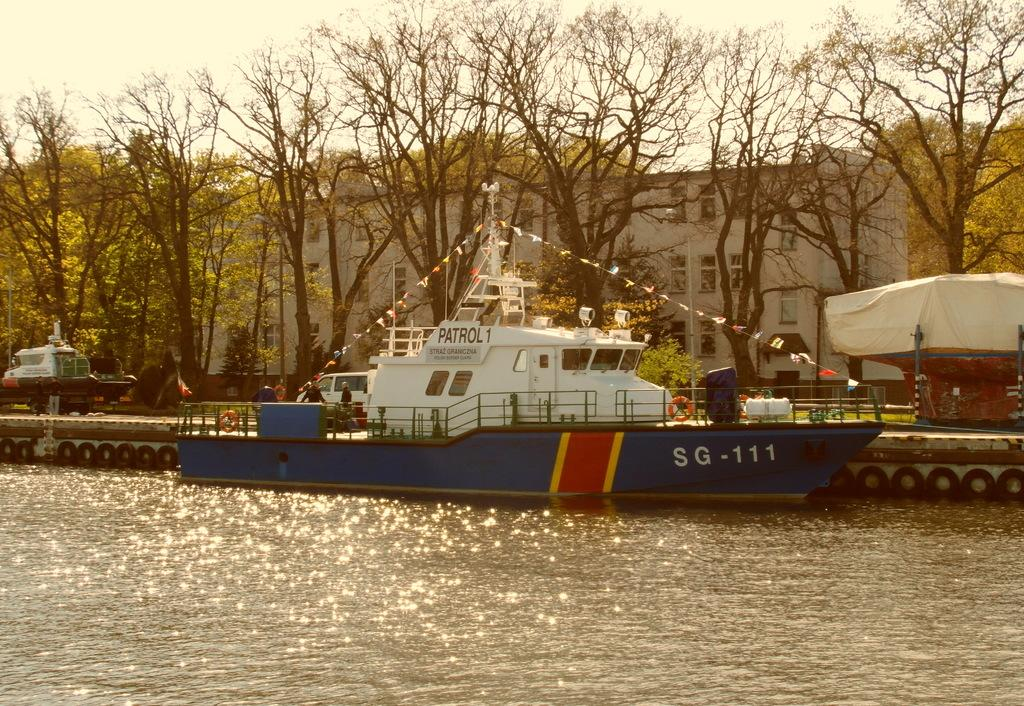What is the main subject in the water in the image? There is a ship in the water in the image. What else can be seen on the ground in the image? There are vehicles on the road in the image. What type of natural scenery is visible in the background of the image? There are trees in the background of the image. What type of man-made structures can be seen in the background of the image? There are buildings in the background of the image. What part of the natural environment is visible in the background of the image? The sky is visible in the background of the image. What type of hole can be seen in the ship in the image? There is no hole visible in the ship in the image. What note is the ship playing in the image? Ships do not play notes, as they are inanimate objects and cannot produce music. 